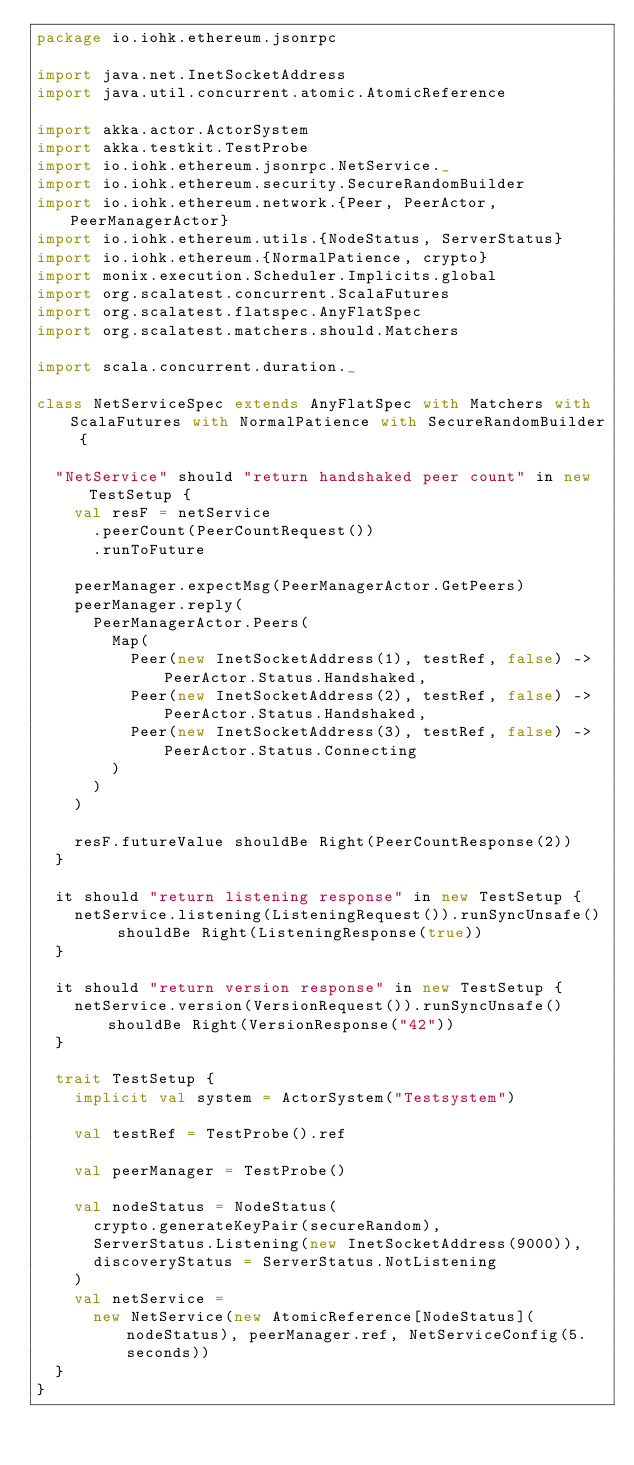Convert code to text. <code><loc_0><loc_0><loc_500><loc_500><_Scala_>package io.iohk.ethereum.jsonrpc

import java.net.InetSocketAddress
import java.util.concurrent.atomic.AtomicReference

import akka.actor.ActorSystem
import akka.testkit.TestProbe
import io.iohk.ethereum.jsonrpc.NetService._
import io.iohk.ethereum.security.SecureRandomBuilder
import io.iohk.ethereum.network.{Peer, PeerActor, PeerManagerActor}
import io.iohk.ethereum.utils.{NodeStatus, ServerStatus}
import io.iohk.ethereum.{NormalPatience, crypto}
import monix.execution.Scheduler.Implicits.global
import org.scalatest.concurrent.ScalaFutures
import org.scalatest.flatspec.AnyFlatSpec
import org.scalatest.matchers.should.Matchers

import scala.concurrent.duration._

class NetServiceSpec extends AnyFlatSpec with Matchers with ScalaFutures with NormalPatience with SecureRandomBuilder {

  "NetService" should "return handshaked peer count" in new TestSetup {
    val resF = netService
      .peerCount(PeerCountRequest())
      .runToFuture

    peerManager.expectMsg(PeerManagerActor.GetPeers)
    peerManager.reply(
      PeerManagerActor.Peers(
        Map(
          Peer(new InetSocketAddress(1), testRef, false) -> PeerActor.Status.Handshaked,
          Peer(new InetSocketAddress(2), testRef, false) -> PeerActor.Status.Handshaked,
          Peer(new InetSocketAddress(3), testRef, false) -> PeerActor.Status.Connecting
        )
      )
    )

    resF.futureValue shouldBe Right(PeerCountResponse(2))
  }

  it should "return listening response" in new TestSetup {
    netService.listening(ListeningRequest()).runSyncUnsafe() shouldBe Right(ListeningResponse(true))
  }

  it should "return version response" in new TestSetup {
    netService.version(VersionRequest()).runSyncUnsafe() shouldBe Right(VersionResponse("42"))
  }

  trait TestSetup {
    implicit val system = ActorSystem("Testsystem")

    val testRef = TestProbe().ref

    val peerManager = TestProbe()

    val nodeStatus = NodeStatus(
      crypto.generateKeyPair(secureRandom),
      ServerStatus.Listening(new InetSocketAddress(9000)),
      discoveryStatus = ServerStatus.NotListening
    )
    val netService =
      new NetService(new AtomicReference[NodeStatus](nodeStatus), peerManager.ref, NetServiceConfig(5.seconds))
  }
}
</code> 